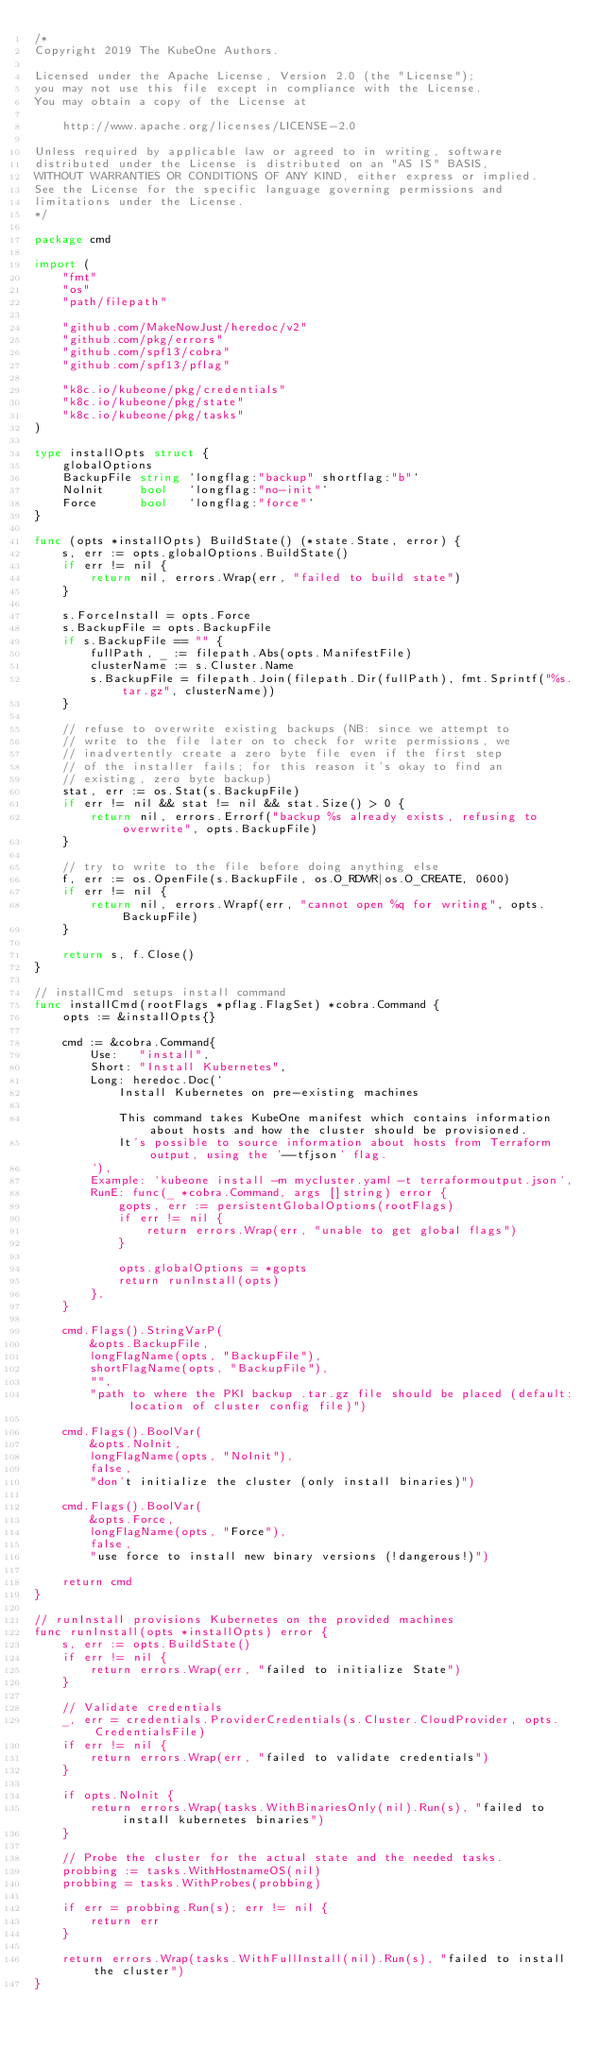Convert code to text. <code><loc_0><loc_0><loc_500><loc_500><_Go_>/*
Copyright 2019 The KubeOne Authors.

Licensed under the Apache License, Version 2.0 (the "License");
you may not use this file except in compliance with the License.
You may obtain a copy of the License at

    http://www.apache.org/licenses/LICENSE-2.0

Unless required by applicable law or agreed to in writing, software
distributed under the License is distributed on an "AS IS" BASIS,
WITHOUT WARRANTIES OR CONDITIONS OF ANY KIND, either express or implied.
See the License for the specific language governing permissions and
limitations under the License.
*/

package cmd

import (
	"fmt"
	"os"
	"path/filepath"

	"github.com/MakeNowJust/heredoc/v2"
	"github.com/pkg/errors"
	"github.com/spf13/cobra"
	"github.com/spf13/pflag"

	"k8c.io/kubeone/pkg/credentials"
	"k8c.io/kubeone/pkg/state"
	"k8c.io/kubeone/pkg/tasks"
)

type installOpts struct {
	globalOptions
	BackupFile string `longflag:"backup" shortflag:"b"`
	NoInit     bool   `longflag:"no-init"`
	Force      bool   `longflag:"force"`
}

func (opts *installOpts) BuildState() (*state.State, error) {
	s, err := opts.globalOptions.BuildState()
	if err != nil {
		return nil, errors.Wrap(err, "failed to build state")
	}

	s.ForceInstall = opts.Force
	s.BackupFile = opts.BackupFile
	if s.BackupFile == "" {
		fullPath, _ := filepath.Abs(opts.ManifestFile)
		clusterName := s.Cluster.Name
		s.BackupFile = filepath.Join(filepath.Dir(fullPath), fmt.Sprintf("%s.tar.gz", clusterName))
	}

	// refuse to overwrite existing backups (NB: since we attempt to
	// write to the file later on to check for write permissions, we
	// inadvertently create a zero byte file even if the first step
	// of the installer fails; for this reason it's okay to find an
	// existing, zero byte backup)
	stat, err := os.Stat(s.BackupFile)
	if err != nil && stat != nil && stat.Size() > 0 {
		return nil, errors.Errorf("backup %s already exists, refusing to overwrite", opts.BackupFile)
	}

	// try to write to the file before doing anything else
	f, err := os.OpenFile(s.BackupFile, os.O_RDWR|os.O_CREATE, 0600)
	if err != nil {
		return nil, errors.Wrapf(err, "cannot open %q for writing", opts.BackupFile)
	}

	return s, f.Close()
}

// installCmd setups install command
func installCmd(rootFlags *pflag.FlagSet) *cobra.Command {
	opts := &installOpts{}

	cmd := &cobra.Command{
		Use:   "install",
		Short: "Install Kubernetes",
		Long: heredoc.Doc(`
			Install Kubernetes on pre-existing machines

			This command takes KubeOne manifest which contains information about hosts and how the cluster should be provisioned.
			It's possible to source information about hosts from Terraform output, using the '--tfjson' flag.
		`),
		Example: `kubeone install -m mycluster.yaml -t terraformoutput.json`,
		RunE: func(_ *cobra.Command, args []string) error {
			gopts, err := persistentGlobalOptions(rootFlags)
			if err != nil {
				return errors.Wrap(err, "unable to get global flags")
			}

			opts.globalOptions = *gopts
			return runInstall(opts)
		},
	}

	cmd.Flags().StringVarP(
		&opts.BackupFile,
		longFlagName(opts, "BackupFile"),
		shortFlagName(opts, "BackupFile"),
		"",
		"path to where the PKI backup .tar.gz file should be placed (default: location of cluster config file)")

	cmd.Flags().BoolVar(
		&opts.NoInit,
		longFlagName(opts, "NoInit"),
		false,
		"don't initialize the cluster (only install binaries)")

	cmd.Flags().BoolVar(
		&opts.Force,
		longFlagName(opts, "Force"),
		false,
		"use force to install new binary versions (!dangerous!)")

	return cmd
}

// runInstall provisions Kubernetes on the provided machines
func runInstall(opts *installOpts) error {
	s, err := opts.BuildState()
	if err != nil {
		return errors.Wrap(err, "failed to initialize State")
	}

	// Validate credentials
	_, err = credentials.ProviderCredentials(s.Cluster.CloudProvider, opts.CredentialsFile)
	if err != nil {
		return errors.Wrap(err, "failed to validate credentials")
	}

	if opts.NoInit {
		return errors.Wrap(tasks.WithBinariesOnly(nil).Run(s), "failed to install kubernetes binaries")
	}

	// Probe the cluster for the actual state and the needed tasks.
	probbing := tasks.WithHostnameOS(nil)
	probbing = tasks.WithProbes(probbing)

	if err = probbing.Run(s); err != nil {
		return err
	}

	return errors.Wrap(tasks.WithFullInstall(nil).Run(s), "failed to install the cluster")
}
</code> 